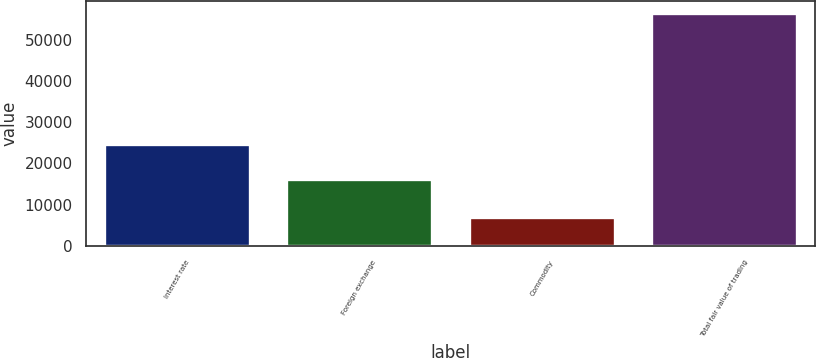Convert chart to OTSL. <chart><loc_0><loc_0><loc_500><loc_500><bar_chart><fcel>Interest rate<fcel>Foreign exchange<fcel>Commodity<fcel>Total fair value of trading<nl><fcel>24673<fcel>16151<fcel>6948<fcel>56523<nl></chart> 